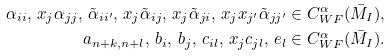<formula> <loc_0><loc_0><loc_500><loc_500>\alpha _ { i i } , \, x _ { j } \alpha _ { j j } , \, \tilde { \alpha } _ { i i ^ { \prime } } , \, x _ { j } \tilde { \alpha } _ { i j } , \, x _ { j } \tilde { \alpha } _ { j i } , \, x _ { j } x _ { j ^ { \prime } } \tilde { \alpha } _ { j j ^ { \prime } } & \in C ^ { \alpha } _ { W F } ( \bar { M } _ { I } ) , \\ a _ { n + k , n + l } , \, b _ { i } , \, b _ { j } , \, c _ { i l } , \, x _ { j } c _ { j l } , \, e _ { l } & \in C ^ { \alpha } _ { W F } ( \bar { M } _ { I } ) .</formula> 